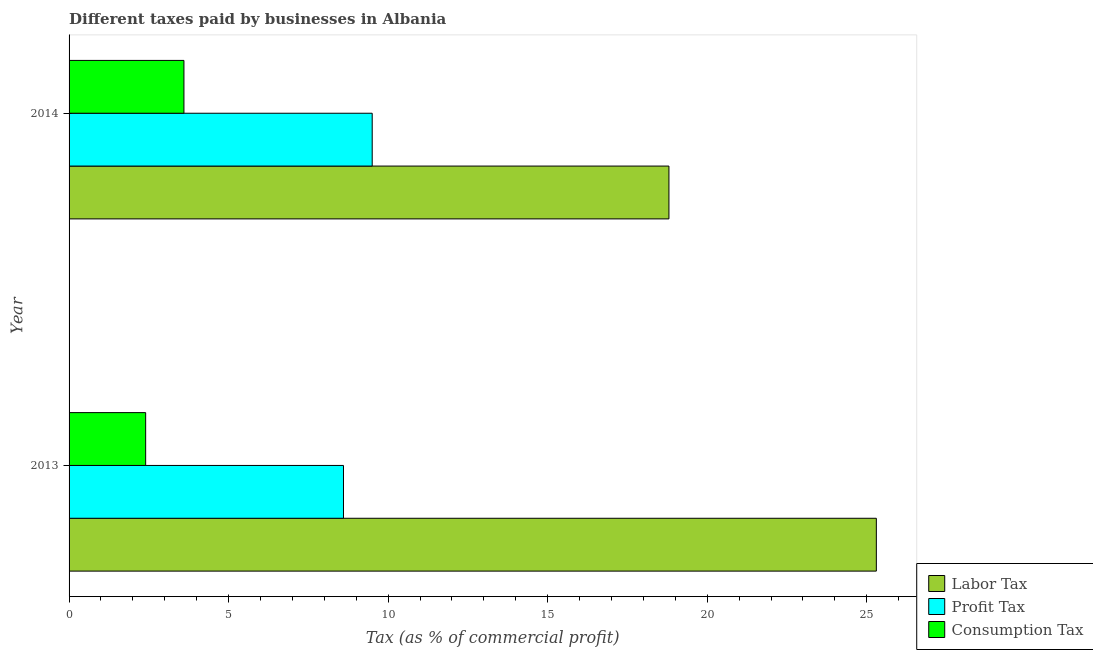How many groups of bars are there?
Give a very brief answer. 2. How many bars are there on the 2nd tick from the top?
Keep it short and to the point. 3. How many bars are there on the 2nd tick from the bottom?
Your response must be concise. 3. In how many cases, is the number of bars for a given year not equal to the number of legend labels?
Provide a short and direct response. 0. Across all years, what is the maximum percentage of profit tax?
Offer a very short reply. 9.5. Across all years, what is the minimum percentage of profit tax?
Your answer should be very brief. 8.6. In which year was the percentage of labor tax maximum?
Your response must be concise. 2013. In which year was the percentage of labor tax minimum?
Offer a very short reply. 2014. What is the total percentage of profit tax in the graph?
Provide a succinct answer. 18.1. What is the difference between the percentage of consumption tax in 2013 and that in 2014?
Ensure brevity in your answer.  -1.2. What is the difference between the percentage of labor tax in 2013 and the percentage of profit tax in 2014?
Provide a succinct answer. 15.8. What is the average percentage of labor tax per year?
Make the answer very short. 22.05. In the year 2014, what is the difference between the percentage of profit tax and percentage of labor tax?
Offer a very short reply. -9.3. What is the ratio of the percentage of profit tax in 2013 to that in 2014?
Keep it short and to the point. 0.91. Is the percentage of labor tax in 2013 less than that in 2014?
Keep it short and to the point. No. In how many years, is the percentage of consumption tax greater than the average percentage of consumption tax taken over all years?
Give a very brief answer. 1. What does the 3rd bar from the top in 2014 represents?
Offer a very short reply. Labor Tax. What does the 2nd bar from the bottom in 2014 represents?
Provide a succinct answer. Profit Tax. How many bars are there?
Provide a short and direct response. 6. Does the graph contain any zero values?
Make the answer very short. No. Does the graph contain grids?
Make the answer very short. No. How many legend labels are there?
Your answer should be compact. 3. How are the legend labels stacked?
Offer a terse response. Vertical. What is the title of the graph?
Offer a terse response. Different taxes paid by businesses in Albania. Does "Transport services" appear as one of the legend labels in the graph?
Offer a very short reply. No. What is the label or title of the X-axis?
Offer a terse response. Tax (as % of commercial profit). What is the label or title of the Y-axis?
Keep it short and to the point. Year. What is the Tax (as % of commercial profit) in Labor Tax in 2013?
Offer a terse response. 25.3. What is the Tax (as % of commercial profit) in Consumption Tax in 2013?
Your response must be concise. 2.4. What is the Tax (as % of commercial profit) in Profit Tax in 2014?
Your answer should be compact. 9.5. What is the Tax (as % of commercial profit) of Consumption Tax in 2014?
Provide a short and direct response. 3.6. Across all years, what is the maximum Tax (as % of commercial profit) in Labor Tax?
Ensure brevity in your answer.  25.3. Across all years, what is the maximum Tax (as % of commercial profit) of Consumption Tax?
Offer a terse response. 3.6. Across all years, what is the minimum Tax (as % of commercial profit) of Profit Tax?
Offer a very short reply. 8.6. Across all years, what is the minimum Tax (as % of commercial profit) in Consumption Tax?
Your response must be concise. 2.4. What is the total Tax (as % of commercial profit) in Labor Tax in the graph?
Make the answer very short. 44.1. What is the difference between the Tax (as % of commercial profit) of Profit Tax in 2013 and that in 2014?
Offer a very short reply. -0.9. What is the difference between the Tax (as % of commercial profit) of Consumption Tax in 2013 and that in 2014?
Provide a succinct answer. -1.2. What is the difference between the Tax (as % of commercial profit) of Labor Tax in 2013 and the Tax (as % of commercial profit) of Consumption Tax in 2014?
Give a very brief answer. 21.7. What is the difference between the Tax (as % of commercial profit) of Profit Tax in 2013 and the Tax (as % of commercial profit) of Consumption Tax in 2014?
Provide a succinct answer. 5. What is the average Tax (as % of commercial profit) of Labor Tax per year?
Offer a terse response. 22.05. What is the average Tax (as % of commercial profit) in Profit Tax per year?
Make the answer very short. 9.05. In the year 2013, what is the difference between the Tax (as % of commercial profit) of Labor Tax and Tax (as % of commercial profit) of Profit Tax?
Your response must be concise. 16.7. In the year 2013, what is the difference between the Tax (as % of commercial profit) in Labor Tax and Tax (as % of commercial profit) in Consumption Tax?
Your response must be concise. 22.9. In the year 2013, what is the difference between the Tax (as % of commercial profit) of Profit Tax and Tax (as % of commercial profit) of Consumption Tax?
Your answer should be compact. 6.2. In the year 2014, what is the difference between the Tax (as % of commercial profit) in Profit Tax and Tax (as % of commercial profit) in Consumption Tax?
Make the answer very short. 5.9. What is the ratio of the Tax (as % of commercial profit) in Labor Tax in 2013 to that in 2014?
Offer a very short reply. 1.35. What is the ratio of the Tax (as % of commercial profit) of Profit Tax in 2013 to that in 2014?
Your response must be concise. 0.91. What is the difference between the highest and the second highest Tax (as % of commercial profit) in Labor Tax?
Your response must be concise. 6.5. What is the difference between the highest and the second highest Tax (as % of commercial profit) of Profit Tax?
Your response must be concise. 0.9. What is the difference between the highest and the lowest Tax (as % of commercial profit) of Consumption Tax?
Provide a short and direct response. 1.2. 